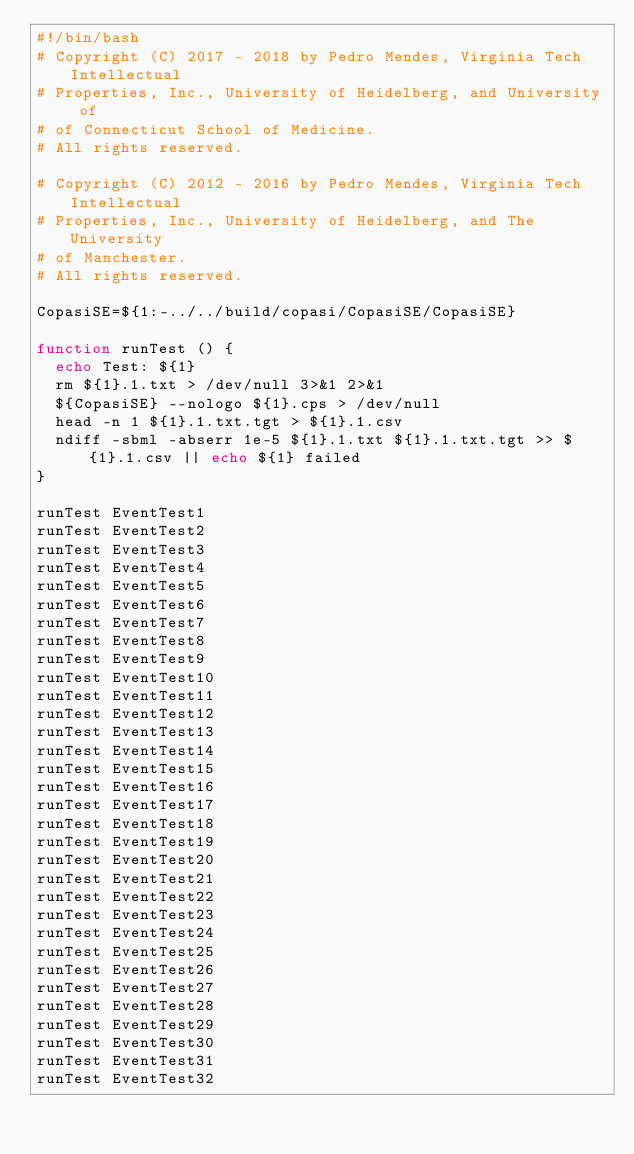Convert code to text. <code><loc_0><loc_0><loc_500><loc_500><_Bash_>#!/bin/bash
# Copyright (C) 2017 - 2018 by Pedro Mendes, Virginia Tech Intellectual 
# Properties, Inc., University of Heidelberg, and University of 
# of Connecticut School of Medicine. 
# All rights reserved. 

# Copyright (C) 2012 - 2016 by Pedro Mendes, Virginia Tech Intellectual 
# Properties, Inc., University of Heidelberg, and The University 
# of Manchester. 
# All rights reserved. 

CopasiSE=${1:-../../build/copasi/CopasiSE/CopasiSE}

function runTest () {
  echo Test: ${1}
  rm ${1}.1.txt > /dev/null 3>&1 2>&1 
  ${CopasiSE} --nologo ${1}.cps > /dev/null
  head -n 1 ${1}.1.txt.tgt > ${1}.1.csv
  ndiff -sbml -abserr 1e-5 ${1}.1.txt ${1}.1.txt.tgt >> ${1}.1.csv || echo ${1} failed
}

runTest EventTest1
runTest EventTest2
runTest EventTest3
runTest EventTest4
runTest EventTest5
runTest EventTest6
runTest EventTest7
runTest EventTest8  
runTest EventTest9
runTest EventTest10
runTest EventTest11
runTest EventTest12
runTest EventTest13
runTest EventTest14
runTest EventTest15
runTest EventTest16
runTest EventTest17
runTest EventTest18
runTest EventTest19
runTest EventTest20
runTest EventTest21
runTest EventTest22
runTest EventTest23
runTest EventTest24
runTest EventTest25
runTest EventTest26
runTest EventTest27
runTest EventTest28
runTest EventTest29
runTest EventTest30
runTest EventTest31
runTest EventTest32
</code> 